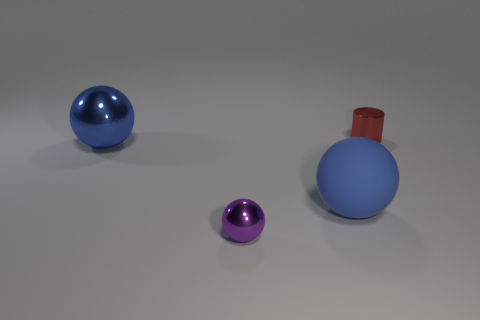Add 2 gray rubber cylinders. How many objects exist? 6 Subtract all spheres. How many objects are left? 1 Subtract all big matte balls. Subtract all large shiny balls. How many objects are left? 2 Add 1 big blue metal spheres. How many big blue metal spheres are left? 2 Add 3 red metal objects. How many red metal objects exist? 4 Subtract 1 red cylinders. How many objects are left? 3 